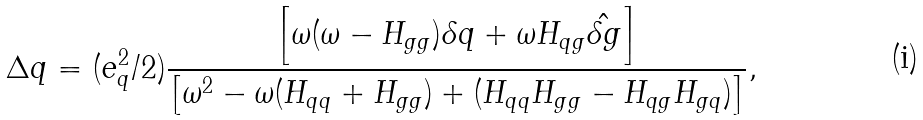Convert formula to latex. <formula><loc_0><loc_0><loc_500><loc_500>\Delta q = ( e ^ { 2 } _ { q } / 2 ) \frac { \left [ \omega ( \omega - H _ { g g } ) \delta q + \omega H _ { q g } \hat { \delta g } \right ] } { \left [ \omega ^ { 2 } - \omega ( H _ { q q } + H _ { g g } ) + ( H _ { q q } H _ { g g } - H _ { q g } H _ { g q } ) \right ] } ,</formula> 